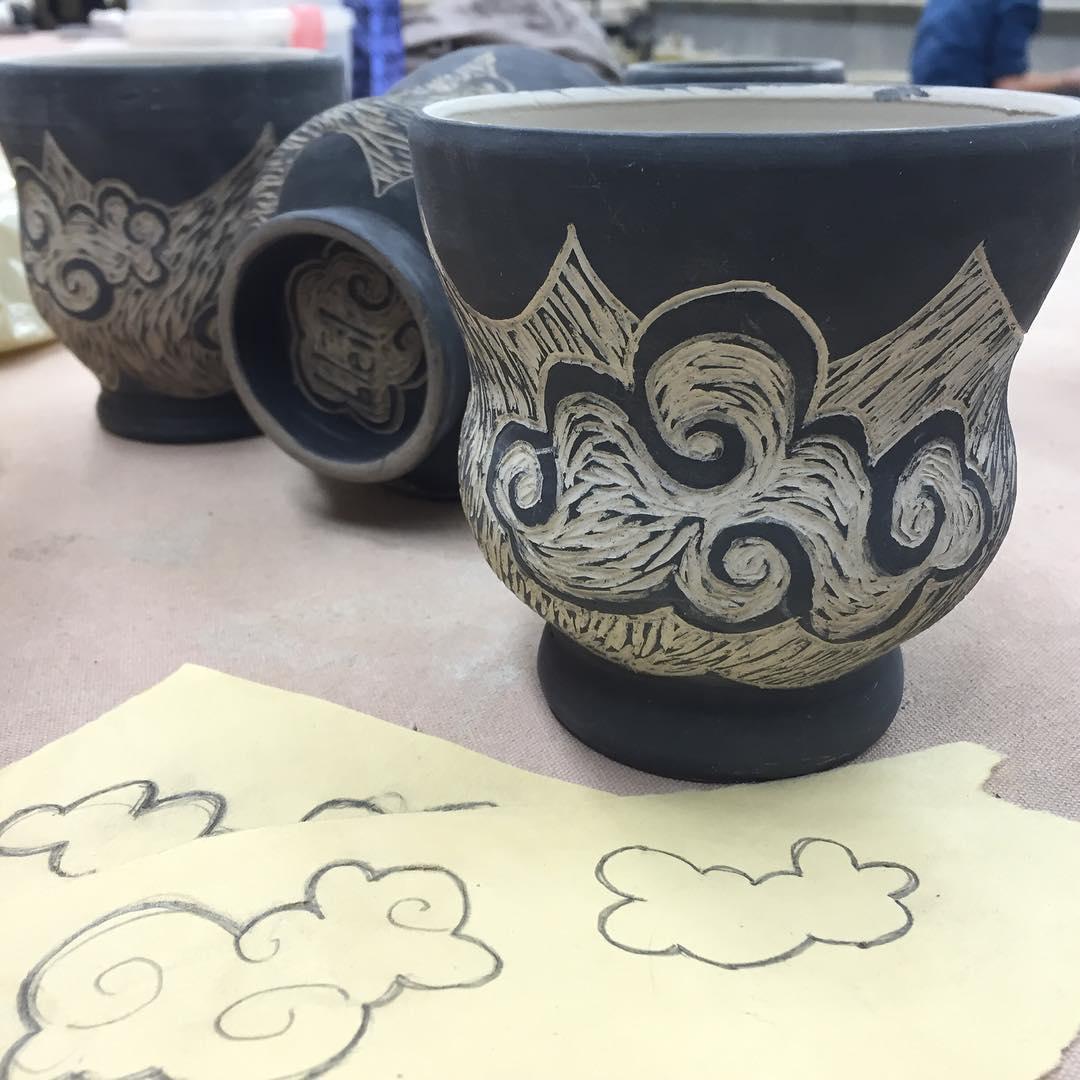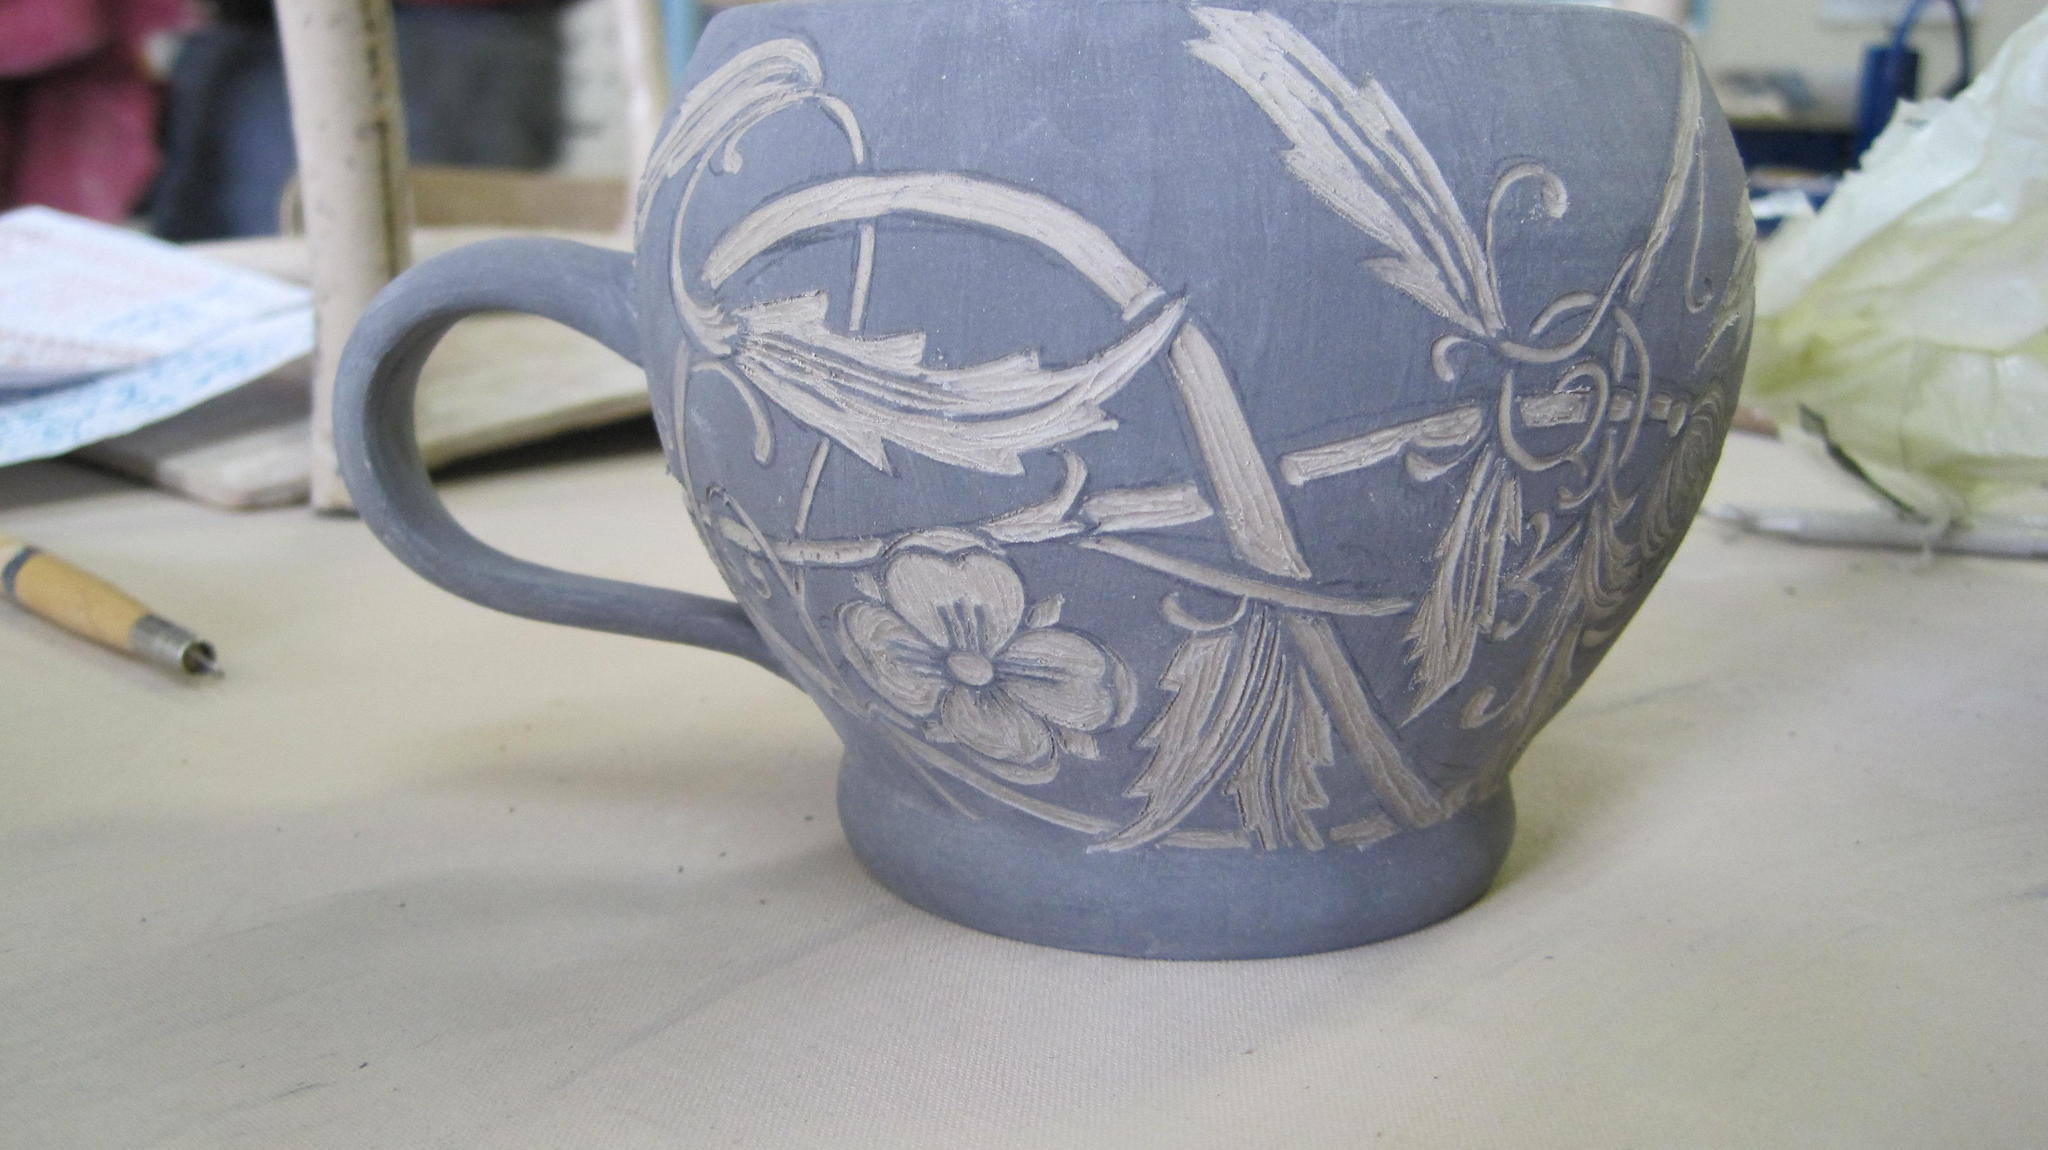The first image is the image on the left, the second image is the image on the right. Considering the images on both sides, is "There are more than 2 cups." valid? Answer yes or no. Yes. The first image is the image on the left, the second image is the image on the right. For the images shown, is this caption "The left and right image contains the same number  of cups." true? Answer yes or no. No. 